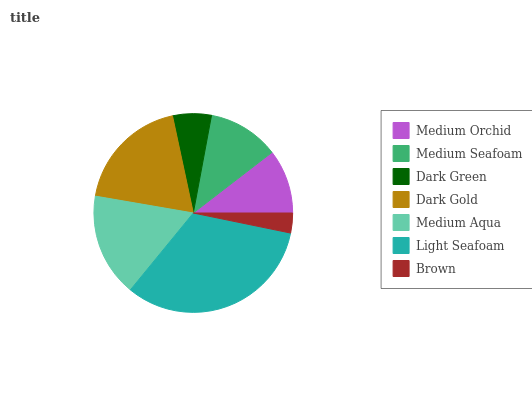Is Brown the minimum?
Answer yes or no. Yes. Is Light Seafoam the maximum?
Answer yes or no. Yes. Is Medium Seafoam the minimum?
Answer yes or no. No. Is Medium Seafoam the maximum?
Answer yes or no. No. Is Medium Seafoam greater than Medium Orchid?
Answer yes or no. Yes. Is Medium Orchid less than Medium Seafoam?
Answer yes or no. Yes. Is Medium Orchid greater than Medium Seafoam?
Answer yes or no. No. Is Medium Seafoam less than Medium Orchid?
Answer yes or no. No. Is Medium Seafoam the high median?
Answer yes or no. Yes. Is Medium Seafoam the low median?
Answer yes or no. Yes. Is Brown the high median?
Answer yes or no. No. Is Brown the low median?
Answer yes or no. No. 